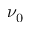Convert formula to latex. <formula><loc_0><loc_0><loc_500><loc_500>\nu _ { 0 }</formula> 